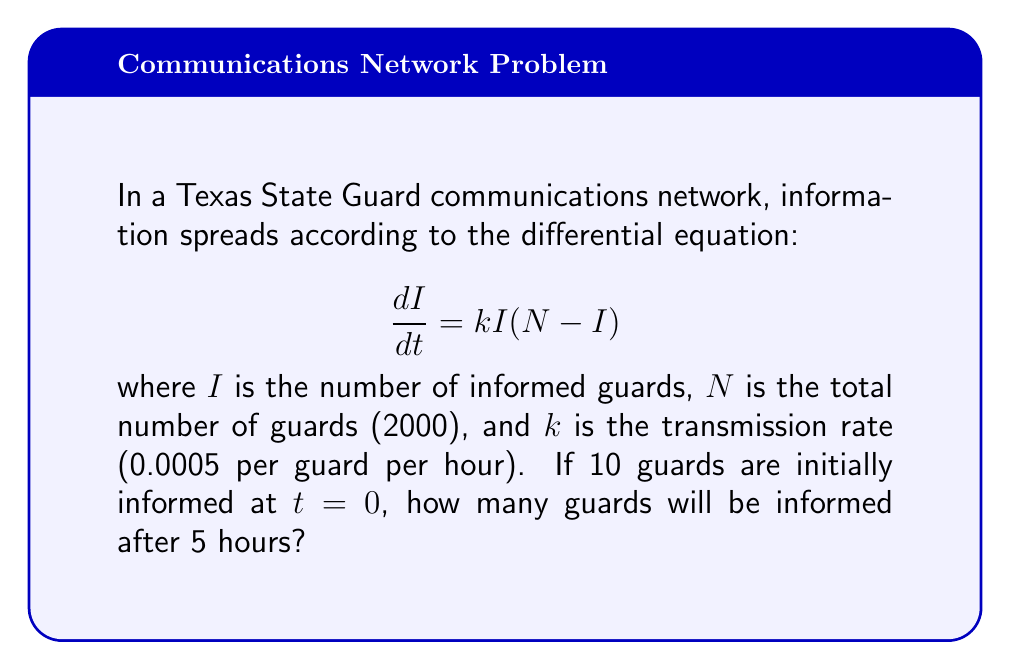Help me with this question. To solve this problem, we need to use the logistic differential equation solution. The steps are as follows:

1) The general solution to the logistic equation $\frac{dI}{dt} = kI(N-I)$ is:

   $$I(t) = \frac{N}{1 + Ce^{-kNt}}$$

   where $C$ is a constant determined by the initial conditions.

2) Given initial conditions: $I(0) = 10$, $N = 2000$, $k = 0.0005$

3) To find $C$, substitute $t=0$ and $I(0) = 10$ into the general solution:

   $$10 = \frac{2000}{1 + C}$$

4) Solve for $C$:
   
   $$C = \frac{2000}{10} - 1 = 199$$

5) Now we have the specific solution:

   $$I(t) = \frac{2000}{1 + 199e^{-0.0005 \cdot 2000t}}$$

6) To find $I(5)$, substitute $t=5$ into this equation:

   $$I(5) = \frac{2000}{1 + 199e^{-0.0005 \cdot 2000 \cdot 5}}$$

7) Simplify:
   
   $$I(5) = \frac{2000}{1 + 199e^{-5}} \approx 49.95$$

8) Since we can't have a fractional number of guards, we round to the nearest whole number.
Answer: After 5 hours, approximately 50 guards will be informed. 